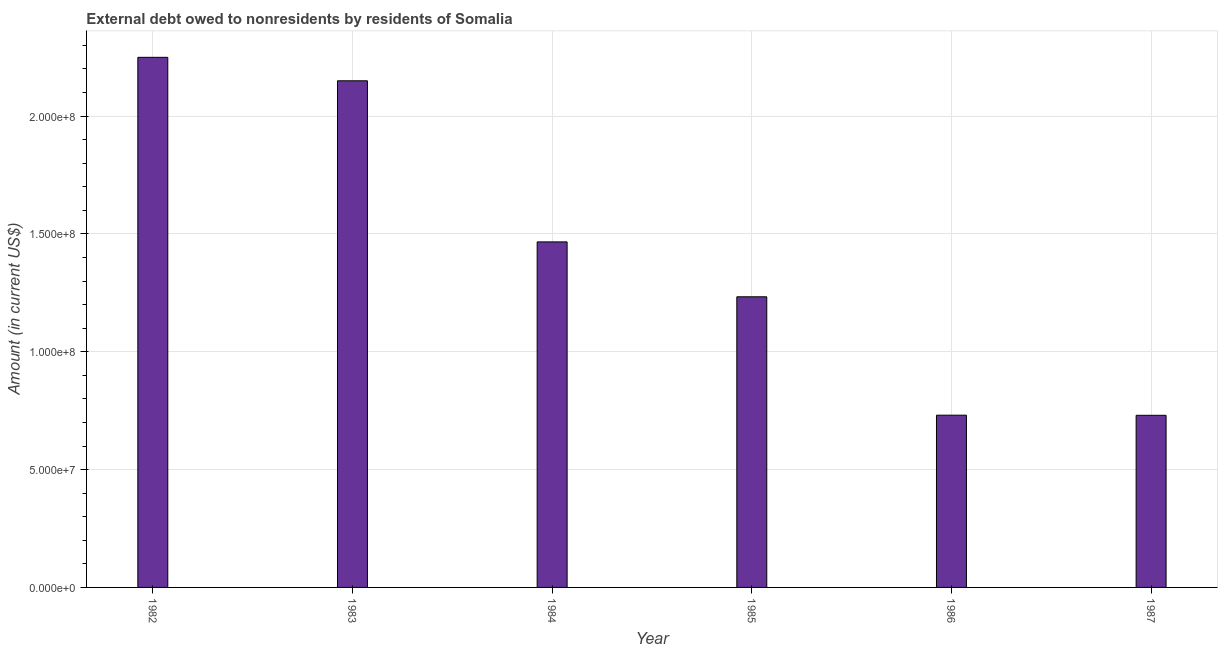Does the graph contain grids?
Offer a terse response. Yes. What is the title of the graph?
Your response must be concise. External debt owed to nonresidents by residents of Somalia. What is the label or title of the X-axis?
Keep it short and to the point. Year. What is the label or title of the Y-axis?
Ensure brevity in your answer.  Amount (in current US$). What is the debt in 1985?
Give a very brief answer. 1.23e+08. Across all years, what is the maximum debt?
Provide a succinct answer. 2.25e+08. Across all years, what is the minimum debt?
Provide a succinct answer. 7.30e+07. In which year was the debt minimum?
Your answer should be very brief. 1987. What is the sum of the debt?
Your answer should be compact. 8.56e+08. What is the difference between the debt in 1984 and 1986?
Your answer should be compact. 7.35e+07. What is the average debt per year?
Ensure brevity in your answer.  1.43e+08. What is the median debt?
Provide a succinct answer. 1.35e+08. Do a majority of the years between 1985 and 1983 (inclusive) have debt greater than 50000000 US$?
Ensure brevity in your answer.  Yes. What is the ratio of the debt in 1982 to that in 1983?
Keep it short and to the point. 1.05. What is the difference between the highest and the second highest debt?
Provide a succinct answer. 9.95e+06. What is the difference between the highest and the lowest debt?
Your answer should be very brief. 1.52e+08. What is the difference between two consecutive major ticks on the Y-axis?
Offer a terse response. 5.00e+07. Are the values on the major ticks of Y-axis written in scientific E-notation?
Your answer should be compact. Yes. What is the Amount (in current US$) in 1982?
Provide a short and direct response. 2.25e+08. What is the Amount (in current US$) in 1983?
Offer a very short reply. 2.15e+08. What is the Amount (in current US$) of 1984?
Give a very brief answer. 1.47e+08. What is the Amount (in current US$) in 1985?
Your answer should be very brief. 1.23e+08. What is the Amount (in current US$) of 1986?
Give a very brief answer. 7.31e+07. What is the Amount (in current US$) of 1987?
Your response must be concise. 7.30e+07. What is the difference between the Amount (in current US$) in 1982 and 1983?
Your response must be concise. 9.95e+06. What is the difference between the Amount (in current US$) in 1982 and 1984?
Offer a terse response. 7.83e+07. What is the difference between the Amount (in current US$) in 1982 and 1985?
Your answer should be very brief. 1.02e+08. What is the difference between the Amount (in current US$) in 1982 and 1986?
Your response must be concise. 1.52e+08. What is the difference between the Amount (in current US$) in 1982 and 1987?
Your answer should be very brief. 1.52e+08. What is the difference between the Amount (in current US$) in 1983 and 1984?
Offer a very short reply. 6.84e+07. What is the difference between the Amount (in current US$) in 1983 and 1985?
Keep it short and to the point. 9.16e+07. What is the difference between the Amount (in current US$) in 1983 and 1986?
Ensure brevity in your answer.  1.42e+08. What is the difference between the Amount (in current US$) in 1983 and 1987?
Ensure brevity in your answer.  1.42e+08. What is the difference between the Amount (in current US$) in 1984 and 1985?
Ensure brevity in your answer.  2.33e+07. What is the difference between the Amount (in current US$) in 1984 and 1986?
Offer a terse response. 7.35e+07. What is the difference between the Amount (in current US$) in 1984 and 1987?
Give a very brief answer. 7.36e+07. What is the difference between the Amount (in current US$) in 1985 and 1986?
Ensure brevity in your answer.  5.02e+07. What is the difference between the Amount (in current US$) in 1985 and 1987?
Give a very brief answer. 5.03e+07. What is the difference between the Amount (in current US$) in 1986 and 1987?
Offer a very short reply. 5.30e+04. What is the ratio of the Amount (in current US$) in 1982 to that in 1983?
Offer a terse response. 1.05. What is the ratio of the Amount (in current US$) in 1982 to that in 1984?
Your response must be concise. 1.53. What is the ratio of the Amount (in current US$) in 1982 to that in 1985?
Provide a short and direct response. 1.82. What is the ratio of the Amount (in current US$) in 1982 to that in 1986?
Ensure brevity in your answer.  3.08. What is the ratio of the Amount (in current US$) in 1982 to that in 1987?
Provide a succinct answer. 3.08. What is the ratio of the Amount (in current US$) in 1983 to that in 1984?
Provide a succinct answer. 1.47. What is the ratio of the Amount (in current US$) in 1983 to that in 1985?
Provide a succinct answer. 1.74. What is the ratio of the Amount (in current US$) in 1983 to that in 1986?
Provide a short and direct response. 2.94. What is the ratio of the Amount (in current US$) in 1983 to that in 1987?
Offer a very short reply. 2.94. What is the ratio of the Amount (in current US$) in 1984 to that in 1985?
Make the answer very short. 1.19. What is the ratio of the Amount (in current US$) in 1984 to that in 1986?
Give a very brief answer. 2.01. What is the ratio of the Amount (in current US$) in 1984 to that in 1987?
Give a very brief answer. 2.01. What is the ratio of the Amount (in current US$) in 1985 to that in 1986?
Provide a succinct answer. 1.69. What is the ratio of the Amount (in current US$) in 1985 to that in 1987?
Keep it short and to the point. 1.69. 